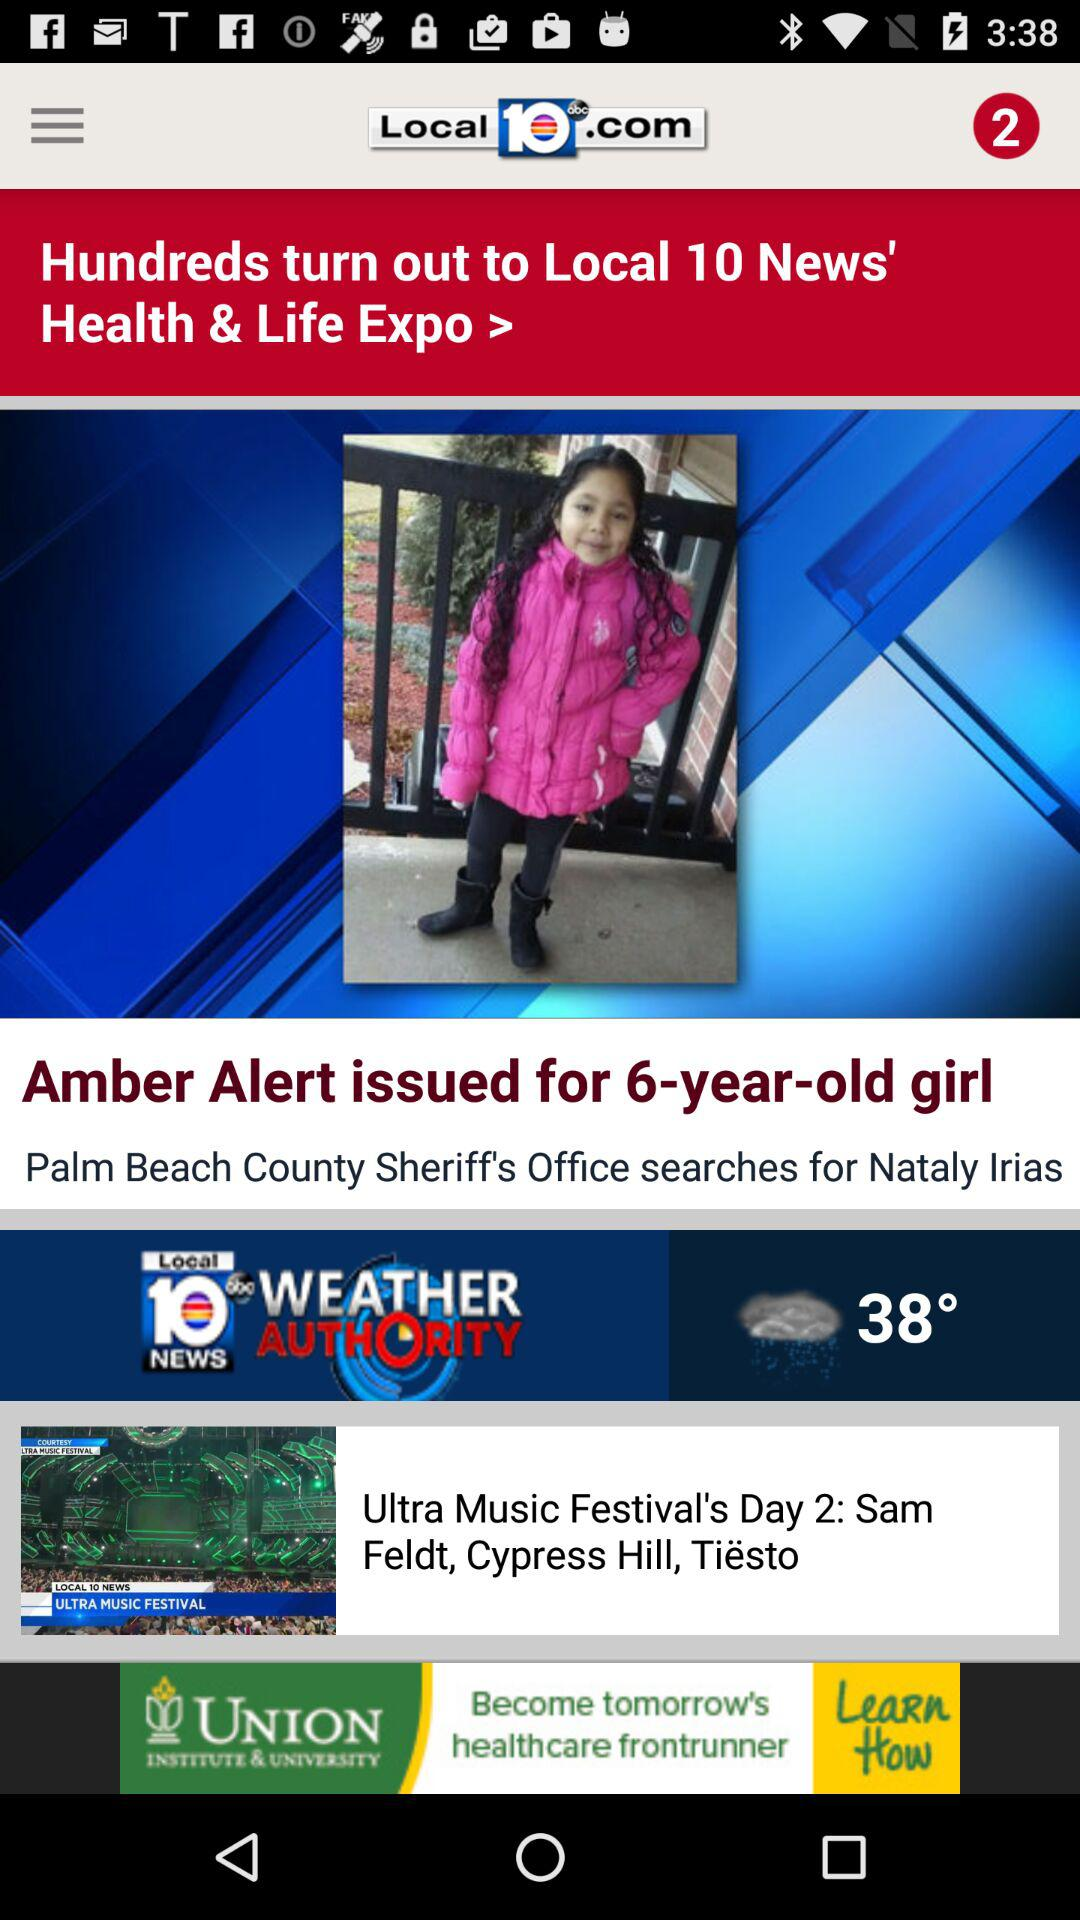What is the temperature? The temperature is 38°. 